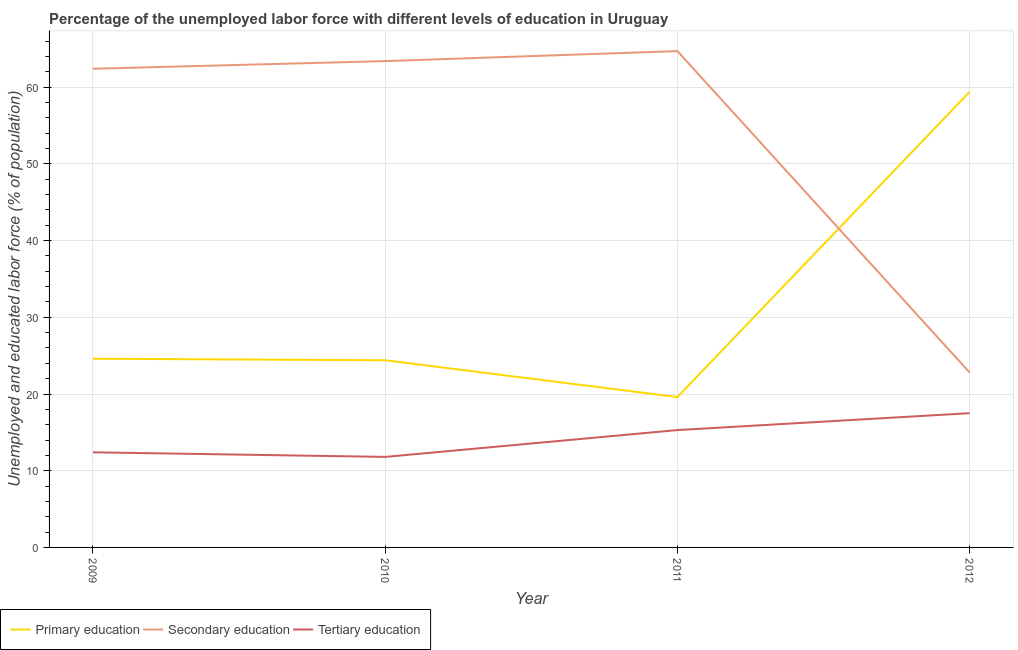How many different coloured lines are there?
Give a very brief answer. 3. Does the line corresponding to percentage of labor force who received primary education intersect with the line corresponding to percentage of labor force who received secondary education?
Provide a short and direct response. Yes. Is the number of lines equal to the number of legend labels?
Your response must be concise. Yes. What is the percentage of labor force who received primary education in 2010?
Make the answer very short. 24.4. Across all years, what is the maximum percentage of labor force who received primary education?
Your answer should be very brief. 59.4. Across all years, what is the minimum percentage of labor force who received primary education?
Give a very brief answer. 19.6. In which year was the percentage of labor force who received tertiary education maximum?
Provide a succinct answer. 2012. What is the total percentage of labor force who received tertiary education in the graph?
Your answer should be compact. 57. What is the difference between the percentage of labor force who received primary education in 2009 and that in 2012?
Make the answer very short. -34.8. What is the difference between the percentage of labor force who received tertiary education in 2010 and the percentage of labor force who received secondary education in 2011?
Your answer should be compact. -52.9. What is the average percentage of labor force who received secondary education per year?
Your answer should be very brief. 53.32. In the year 2010, what is the difference between the percentage of labor force who received primary education and percentage of labor force who received secondary education?
Give a very brief answer. -39. What is the ratio of the percentage of labor force who received tertiary education in 2011 to that in 2012?
Ensure brevity in your answer.  0.87. Is the difference between the percentage of labor force who received primary education in 2010 and 2012 greater than the difference between the percentage of labor force who received tertiary education in 2010 and 2012?
Provide a short and direct response. No. What is the difference between the highest and the second highest percentage of labor force who received primary education?
Your answer should be very brief. 34.8. What is the difference between the highest and the lowest percentage of labor force who received tertiary education?
Give a very brief answer. 5.7. In how many years, is the percentage of labor force who received secondary education greater than the average percentage of labor force who received secondary education taken over all years?
Provide a short and direct response. 3. Is the sum of the percentage of labor force who received secondary education in 2011 and 2012 greater than the maximum percentage of labor force who received tertiary education across all years?
Offer a very short reply. Yes. Does the percentage of labor force who received primary education monotonically increase over the years?
Make the answer very short. No. Is the percentage of labor force who received secondary education strictly less than the percentage of labor force who received tertiary education over the years?
Your response must be concise. No. How many lines are there?
Your answer should be compact. 3. Does the graph contain grids?
Offer a terse response. Yes. Where does the legend appear in the graph?
Your answer should be compact. Bottom left. How are the legend labels stacked?
Offer a very short reply. Horizontal. What is the title of the graph?
Provide a succinct answer. Percentage of the unemployed labor force with different levels of education in Uruguay. Does "Transport equipments" appear as one of the legend labels in the graph?
Offer a terse response. No. What is the label or title of the Y-axis?
Keep it short and to the point. Unemployed and educated labor force (% of population). What is the Unemployed and educated labor force (% of population) of Primary education in 2009?
Ensure brevity in your answer.  24.6. What is the Unemployed and educated labor force (% of population) in Secondary education in 2009?
Make the answer very short. 62.4. What is the Unemployed and educated labor force (% of population) in Tertiary education in 2009?
Keep it short and to the point. 12.4. What is the Unemployed and educated labor force (% of population) of Primary education in 2010?
Make the answer very short. 24.4. What is the Unemployed and educated labor force (% of population) in Secondary education in 2010?
Provide a succinct answer. 63.4. What is the Unemployed and educated labor force (% of population) in Tertiary education in 2010?
Your response must be concise. 11.8. What is the Unemployed and educated labor force (% of population) of Primary education in 2011?
Make the answer very short. 19.6. What is the Unemployed and educated labor force (% of population) of Secondary education in 2011?
Provide a succinct answer. 64.7. What is the Unemployed and educated labor force (% of population) in Tertiary education in 2011?
Offer a very short reply. 15.3. What is the Unemployed and educated labor force (% of population) in Primary education in 2012?
Keep it short and to the point. 59.4. What is the Unemployed and educated labor force (% of population) of Secondary education in 2012?
Ensure brevity in your answer.  22.8. Across all years, what is the maximum Unemployed and educated labor force (% of population) of Primary education?
Offer a terse response. 59.4. Across all years, what is the maximum Unemployed and educated labor force (% of population) of Secondary education?
Your answer should be very brief. 64.7. Across all years, what is the maximum Unemployed and educated labor force (% of population) in Tertiary education?
Offer a very short reply. 17.5. Across all years, what is the minimum Unemployed and educated labor force (% of population) in Primary education?
Provide a short and direct response. 19.6. Across all years, what is the minimum Unemployed and educated labor force (% of population) in Secondary education?
Give a very brief answer. 22.8. Across all years, what is the minimum Unemployed and educated labor force (% of population) in Tertiary education?
Ensure brevity in your answer.  11.8. What is the total Unemployed and educated labor force (% of population) in Primary education in the graph?
Your answer should be very brief. 128. What is the total Unemployed and educated labor force (% of population) in Secondary education in the graph?
Make the answer very short. 213.3. What is the difference between the Unemployed and educated labor force (% of population) of Secondary education in 2009 and that in 2010?
Your answer should be very brief. -1. What is the difference between the Unemployed and educated labor force (% of population) in Tertiary education in 2009 and that in 2010?
Give a very brief answer. 0.6. What is the difference between the Unemployed and educated labor force (% of population) in Secondary education in 2009 and that in 2011?
Your response must be concise. -2.3. What is the difference between the Unemployed and educated labor force (% of population) in Primary education in 2009 and that in 2012?
Provide a succinct answer. -34.8. What is the difference between the Unemployed and educated labor force (% of population) in Secondary education in 2009 and that in 2012?
Offer a terse response. 39.6. What is the difference between the Unemployed and educated labor force (% of population) of Tertiary education in 2010 and that in 2011?
Provide a succinct answer. -3.5. What is the difference between the Unemployed and educated labor force (% of population) in Primary education in 2010 and that in 2012?
Provide a succinct answer. -35. What is the difference between the Unemployed and educated labor force (% of population) in Secondary education in 2010 and that in 2012?
Give a very brief answer. 40.6. What is the difference between the Unemployed and educated labor force (% of population) in Primary education in 2011 and that in 2012?
Offer a very short reply. -39.8. What is the difference between the Unemployed and educated labor force (% of population) of Secondary education in 2011 and that in 2012?
Offer a terse response. 41.9. What is the difference between the Unemployed and educated labor force (% of population) in Primary education in 2009 and the Unemployed and educated labor force (% of population) in Secondary education in 2010?
Ensure brevity in your answer.  -38.8. What is the difference between the Unemployed and educated labor force (% of population) in Primary education in 2009 and the Unemployed and educated labor force (% of population) in Tertiary education in 2010?
Your answer should be very brief. 12.8. What is the difference between the Unemployed and educated labor force (% of population) of Secondary education in 2009 and the Unemployed and educated labor force (% of population) of Tertiary education in 2010?
Keep it short and to the point. 50.6. What is the difference between the Unemployed and educated labor force (% of population) of Primary education in 2009 and the Unemployed and educated labor force (% of population) of Secondary education in 2011?
Provide a short and direct response. -40.1. What is the difference between the Unemployed and educated labor force (% of population) of Primary education in 2009 and the Unemployed and educated labor force (% of population) of Tertiary education in 2011?
Keep it short and to the point. 9.3. What is the difference between the Unemployed and educated labor force (% of population) in Secondary education in 2009 and the Unemployed and educated labor force (% of population) in Tertiary education in 2011?
Keep it short and to the point. 47.1. What is the difference between the Unemployed and educated labor force (% of population) of Primary education in 2009 and the Unemployed and educated labor force (% of population) of Secondary education in 2012?
Provide a short and direct response. 1.8. What is the difference between the Unemployed and educated labor force (% of population) in Primary education in 2009 and the Unemployed and educated labor force (% of population) in Tertiary education in 2012?
Provide a short and direct response. 7.1. What is the difference between the Unemployed and educated labor force (% of population) in Secondary education in 2009 and the Unemployed and educated labor force (% of population) in Tertiary education in 2012?
Your answer should be compact. 44.9. What is the difference between the Unemployed and educated labor force (% of population) in Primary education in 2010 and the Unemployed and educated labor force (% of population) in Secondary education in 2011?
Provide a short and direct response. -40.3. What is the difference between the Unemployed and educated labor force (% of population) of Secondary education in 2010 and the Unemployed and educated labor force (% of population) of Tertiary education in 2011?
Make the answer very short. 48.1. What is the difference between the Unemployed and educated labor force (% of population) in Secondary education in 2010 and the Unemployed and educated labor force (% of population) in Tertiary education in 2012?
Offer a terse response. 45.9. What is the difference between the Unemployed and educated labor force (% of population) in Primary education in 2011 and the Unemployed and educated labor force (% of population) in Secondary education in 2012?
Offer a terse response. -3.2. What is the difference between the Unemployed and educated labor force (% of population) of Primary education in 2011 and the Unemployed and educated labor force (% of population) of Tertiary education in 2012?
Ensure brevity in your answer.  2.1. What is the difference between the Unemployed and educated labor force (% of population) in Secondary education in 2011 and the Unemployed and educated labor force (% of population) in Tertiary education in 2012?
Give a very brief answer. 47.2. What is the average Unemployed and educated labor force (% of population) of Secondary education per year?
Keep it short and to the point. 53.33. What is the average Unemployed and educated labor force (% of population) in Tertiary education per year?
Offer a very short reply. 14.25. In the year 2009, what is the difference between the Unemployed and educated labor force (% of population) of Primary education and Unemployed and educated labor force (% of population) of Secondary education?
Your answer should be very brief. -37.8. In the year 2009, what is the difference between the Unemployed and educated labor force (% of population) in Primary education and Unemployed and educated labor force (% of population) in Tertiary education?
Ensure brevity in your answer.  12.2. In the year 2010, what is the difference between the Unemployed and educated labor force (% of population) in Primary education and Unemployed and educated labor force (% of population) in Secondary education?
Provide a short and direct response. -39. In the year 2010, what is the difference between the Unemployed and educated labor force (% of population) of Primary education and Unemployed and educated labor force (% of population) of Tertiary education?
Offer a terse response. 12.6. In the year 2010, what is the difference between the Unemployed and educated labor force (% of population) in Secondary education and Unemployed and educated labor force (% of population) in Tertiary education?
Give a very brief answer. 51.6. In the year 2011, what is the difference between the Unemployed and educated labor force (% of population) in Primary education and Unemployed and educated labor force (% of population) in Secondary education?
Give a very brief answer. -45.1. In the year 2011, what is the difference between the Unemployed and educated labor force (% of population) in Primary education and Unemployed and educated labor force (% of population) in Tertiary education?
Offer a terse response. 4.3. In the year 2011, what is the difference between the Unemployed and educated labor force (% of population) of Secondary education and Unemployed and educated labor force (% of population) of Tertiary education?
Give a very brief answer. 49.4. In the year 2012, what is the difference between the Unemployed and educated labor force (% of population) in Primary education and Unemployed and educated labor force (% of population) in Secondary education?
Give a very brief answer. 36.6. In the year 2012, what is the difference between the Unemployed and educated labor force (% of population) in Primary education and Unemployed and educated labor force (% of population) in Tertiary education?
Keep it short and to the point. 41.9. In the year 2012, what is the difference between the Unemployed and educated labor force (% of population) in Secondary education and Unemployed and educated labor force (% of population) in Tertiary education?
Make the answer very short. 5.3. What is the ratio of the Unemployed and educated labor force (% of population) in Primary education in 2009 to that in 2010?
Provide a succinct answer. 1.01. What is the ratio of the Unemployed and educated labor force (% of population) of Secondary education in 2009 to that in 2010?
Ensure brevity in your answer.  0.98. What is the ratio of the Unemployed and educated labor force (% of population) in Tertiary education in 2009 to that in 2010?
Make the answer very short. 1.05. What is the ratio of the Unemployed and educated labor force (% of population) of Primary education in 2009 to that in 2011?
Provide a succinct answer. 1.26. What is the ratio of the Unemployed and educated labor force (% of population) in Secondary education in 2009 to that in 2011?
Keep it short and to the point. 0.96. What is the ratio of the Unemployed and educated labor force (% of population) in Tertiary education in 2009 to that in 2011?
Make the answer very short. 0.81. What is the ratio of the Unemployed and educated labor force (% of population) of Primary education in 2009 to that in 2012?
Your answer should be very brief. 0.41. What is the ratio of the Unemployed and educated labor force (% of population) in Secondary education in 2009 to that in 2012?
Your answer should be very brief. 2.74. What is the ratio of the Unemployed and educated labor force (% of population) of Tertiary education in 2009 to that in 2012?
Provide a short and direct response. 0.71. What is the ratio of the Unemployed and educated labor force (% of population) of Primary education in 2010 to that in 2011?
Your answer should be compact. 1.24. What is the ratio of the Unemployed and educated labor force (% of population) in Secondary education in 2010 to that in 2011?
Ensure brevity in your answer.  0.98. What is the ratio of the Unemployed and educated labor force (% of population) in Tertiary education in 2010 to that in 2011?
Keep it short and to the point. 0.77. What is the ratio of the Unemployed and educated labor force (% of population) in Primary education in 2010 to that in 2012?
Ensure brevity in your answer.  0.41. What is the ratio of the Unemployed and educated labor force (% of population) in Secondary education in 2010 to that in 2012?
Make the answer very short. 2.78. What is the ratio of the Unemployed and educated labor force (% of population) of Tertiary education in 2010 to that in 2012?
Provide a succinct answer. 0.67. What is the ratio of the Unemployed and educated labor force (% of population) of Primary education in 2011 to that in 2012?
Keep it short and to the point. 0.33. What is the ratio of the Unemployed and educated labor force (% of population) in Secondary education in 2011 to that in 2012?
Give a very brief answer. 2.84. What is the ratio of the Unemployed and educated labor force (% of population) of Tertiary education in 2011 to that in 2012?
Your answer should be compact. 0.87. What is the difference between the highest and the second highest Unemployed and educated labor force (% of population) of Primary education?
Your response must be concise. 34.8. What is the difference between the highest and the lowest Unemployed and educated labor force (% of population) in Primary education?
Offer a terse response. 39.8. What is the difference between the highest and the lowest Unemployed and educated labor force (% of population) of Secondary education?
Provide a short and direct response. 41.9. What is the difference between the highest and the lowest Unemployed and educated labor force (% of population) of Tertiary education?
Ensure brevity in your answer.  5.7. 